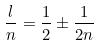Convert formula to latex. <formula><loc_0><loc_0><loc_500><loc_500>\frac { l } { n } = \frac { 1 } { 2 } \pm \frac { 1 } { 2 n }</formula> 